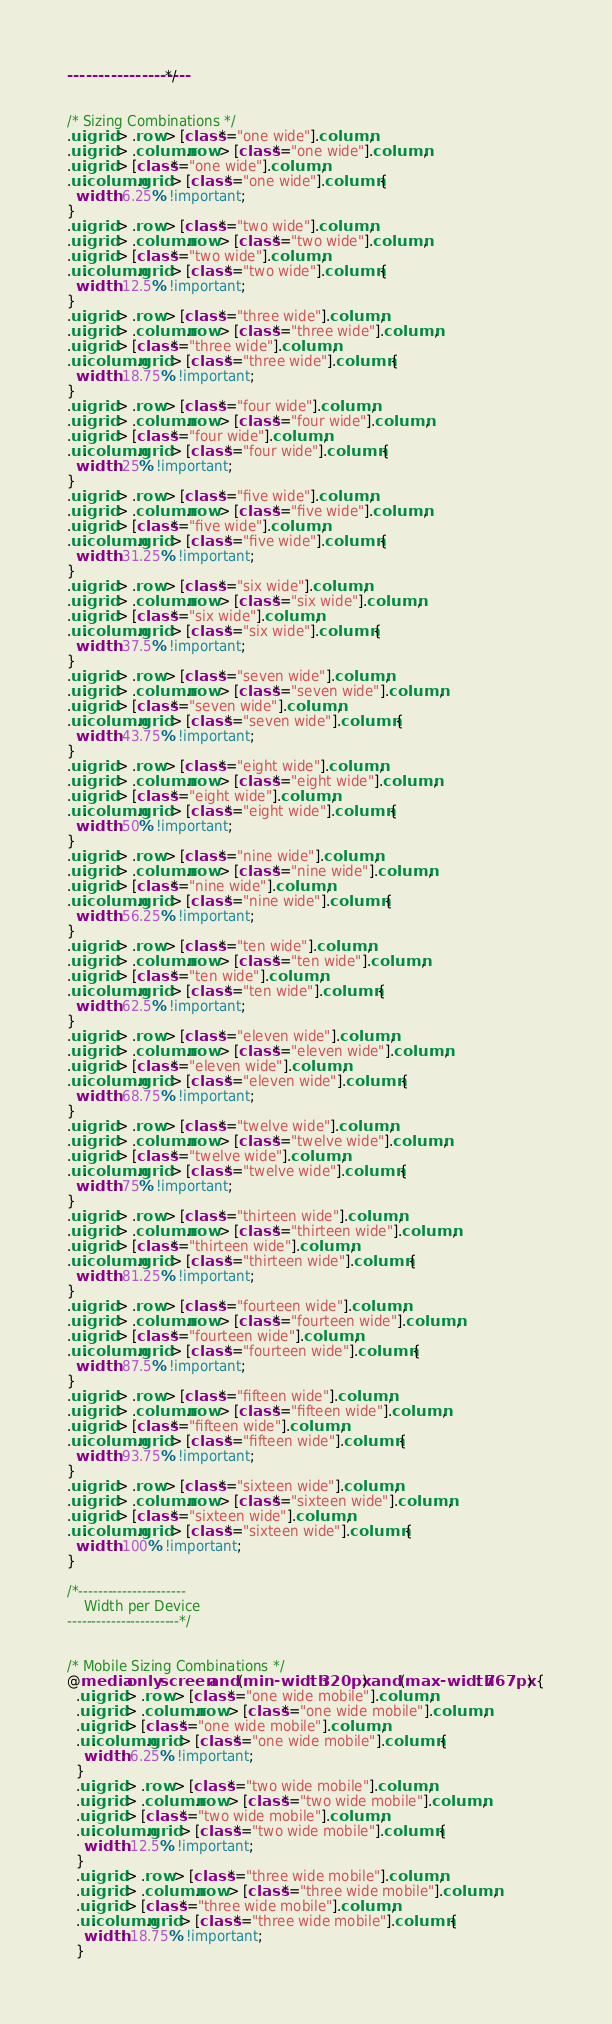<code> <loc_0><loc_0><loc_500><loc_500><_CSS_>--------------------*/


/* Sizing Combinations */
.ui.grid > .row > [class*="one wide"].column,
.ui.grid > .column.row > [class*="one wide"].column,
.ui.grid > [class*="one wide"].column,
.ui.column.grid > [class*="one wide"].column {
  width: 6.25% !important;
}
.ui.grid > .row > [class*="two wide"].column,
.ui.grid > .column.row > [class*="two wide"].column,
.ui.grid > [class*="two wide"].column,
.ui.column.grid > [class*="two wide"].column {
  width: 12.5% !important;
}
.ui.grid > .row > [class*="three wide"].column,
.ui.grid > .column.row > [class*="three wide"].column,
.ui.grid > [class*="three wide"].column,
.ui.column.grid > [class*="three wide"].column {
  width: 18.75% !important;
}
.ui.grid > .row > [class*="four wide"].column,
.ui.grid > .column.row > [class*="four wide"].column,
.ui.grid > [class*="four wide"].column,
.ui.column.grid > [class*="four wide"].column {
  width: 25% !important;
}
.ui.grid > .row > [class*="five wide"].column,
.ui.grid > .column.row > [class*="five wide"].column,
.ui.grid > [class*="five wide"].column,
.ui.column.grid > [class*="five wide"].column {
  width: 31.25% !important;
}
.ui.grid > .row > [class*="six wide"].column,
.ui.grid > .column.row > [class*="six wide"].column,
.ui.grid > [class*="six wide"].column,
.ui.column.grid > [class*="six wide"].column {
  width: 37.5% !important;
}
.ui.grid > .row > [class*="seven wide"].column,
.ui.grid > .column.row > [class*="seven wide"].column,
.ui.grid > [class*="seven wide"].column,
.ui.column.grid > [class*="seven wide"].column {
  width: 43.75% !important;
}
.ui.grid > .row > [class*="eight wide"].column,
.ui.grid > .column.row > [class*="eight wide"].column,
.ui.grid > [class*="eight wide"].column,
.ui.column.grid > [class*="eight wide"].column {
  width: 50% !important;
}
.ui.grid > .row > [class*="nine wide"].column,
.ui.grid > .column.row > [class*="nine wide"].column,
.ui.grid > [class*="nine wide"].column,
.ui.column.grid > [class*="nine wide"].column {
  width: 56.25% !important;
}
.ui.grid > .row > [class*="ten wide"].column,
.ui.grid > .column.row > [class*="ten wide"].column,
.ui.grid > [class*="ten wide"].column,
.ui.column.grid > [class*="ten wide"].column {
  width: 62.5% !important;
}
.ui.grid > .row > [class*="eleven wide"].column,
.ui.grid > .column.row > [class*="eleven wide"].column,
.ui.grid > [class*="eleven wide"].column,
.ui.column.grid > [class*="eleven wide"].column {
  width: 68.75% !important;
}
.ui.grid > .row > [class*="twelve wide"].column,
.ui.grid > .column.row > [class*="twelve wide"].column,
.ui.grid > [class*="twelve wide"].column,
.ui.column.grid > [class*="twelve wide"].column {
  width: 75% !important;
}
.ui.grid > .row > [class*="thirteen wide"].column,
.ui.grid > .column.row > [class*="thirteen wide"].column,
.ui.grid > [class*="thirteen wide"].column,
.ui.column.grid > [class*="thirteen wide"].column {
  width: 81.25% !important;
}
.ui.grid > .row > [class*="fourteen wide"].column,
.ui.grid > .column.row > [class*="fourteen wide"].column,
.ui.grid > [class*="fourteen wide"].column,
.ui.column.grid > [class*="fourteen wide"].column {
  width: 87.5% !important;
}
.ui.grid > .row > [class*="fifteen wide"].column,
.ui.grid > .column.row > [class*="fifteen wide"].column,
.ui.grid > [class*="fifteen wide"].column,
.ui.column.grid > [class*="fifteen wide"].column {
  width: 93.75% !important;
}
.ui.grid > .row > [class*="sixteen wide"].column,
.ui.grid > .column.row > [class*="sixteen wide"].column,
.ui.grid > [class*="sixteen wide"].column,
.ui.column.grid > [class*="sixteen wide"].column {
  width: 100% !important;
}

/*----------------------
    Width per Device
-----------------------*/


/* Mobile Sizing Combinations */
@media only screen and (min-width: 320px) and (max-width: 767px) {
  .ui.grid > .row > [class*="one wide mobile"].column,
  .ui.grid > .column.row > [class*="one wide mobile"].column,
  .ui.grid > [class*="one wide mobile"].column,
  .ui.column.grid > [class*="one wide mobile"].column {
    width: 6.25% !important;
  }
  .ui.grid > .row > [class*="two wide mobile"].column,
  .ui.grid > .column.row > [class*="two wide mobile"].column,
  .ui.grid > [class*="two wide mobile"].column,
  .ui.column.grid > [class*="two wide mobile"].column {
    width: 12.5% !important;
  }
  .ui.grid > .row > [class*="three wide mobile"].column,
  .ui.grid > .column.row > [class*="three wide mobile"].column,
  .ui.grid > [class*="three wide mobile"].column,
  .ui.column.grid > [class*="three wide mobile"].column {
    width: 18.75% !important;
  }</code> 